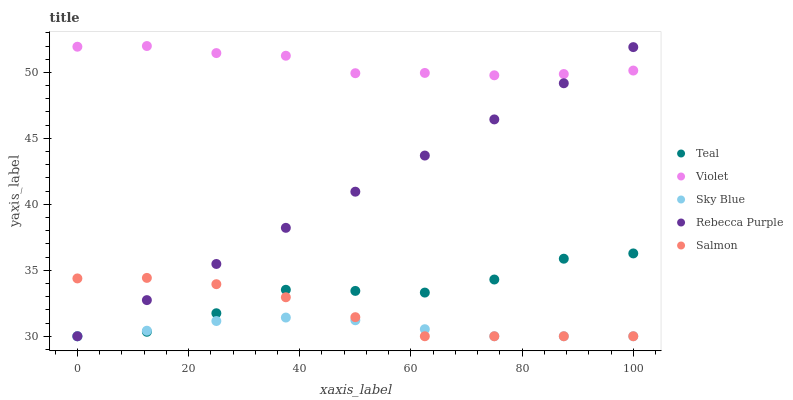Does Sky Blue have the minimum area under the curve?
Answer yes or no. Yes. Does Violet have the maximum area under the curve?
Answer yes or no. Yes. Does Salmon have the minimum area under the curve?
Answer yes or no. No. Does Salmon have the maximum area under the curve?
Answer yes or no. No. Is Rebecca Purple the smoothest?
Answer yes or no. Yes. Is Teal the roughest?
Answer yes or no. Yes. Is Salmon the smoothest?
Answer yes or no. No. Is Salmon the roughest?
Answer yes or no. No. Does Sky Blue have the lowest value?
Answer yes or no. Yes. Does Violet have the lowest value?
Answer yes or no. No. Does Violet have the highest value?
Answer yes or no. Yes. Does Salmon have the highest value?
Answer yes or no. No. Is Salmon less than Violet?
Answer yes or no. Yes. Is Violet greater than Teal?
Answer yes or no. Yes. Does Salmon intersect Teal?
Answer yes or no. Yes. Is Salmon less than Teal?
Answer yes or no. No. Is Salmon greater than Teal?
Answer yes or no. No. Does Salmon intersect Violet?
Answer yes or no. No. 